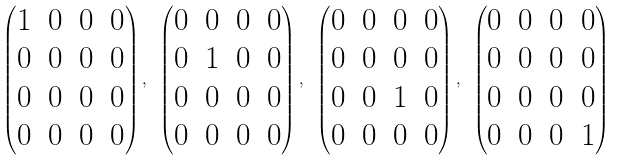Convert formula to latex. <formula><loc_0><loc_0><loc_500><loc_500>\begin{pmatrix} 1 & 0 & 0 & 0 \\ 0 & 0 & 0 & 0 \\ 0 & 0 & 0 & 0 \\ 0 & 0 & 0 & 0 \end{pmatrix} , \ \begin{pmatrix} 0 & 0 & 0 & 0 \\ 0 & 1 & 0 & 0 \\ 0 & 0 & 0 & 0 \\ 0 & 0 & 0 & 0 \end{pmatrix} , \ \begin{pmatrix} 0 & 0 & 0 & 0 \\ 0 & 0 & 0 & 0 \\ 0 & 0 & 1 & 0 \\ 0 & 0 & 0 & 0 \end{pmatrix} , \ \begin{pmatrix} 0 & 0 & 0 & 0 \\ 0 & 0 & 0 & 0 \\ 0 & 0 & 0 & 0 \\ 0 & 0 & 0 & 1 \end{pmatrix}</formula> 